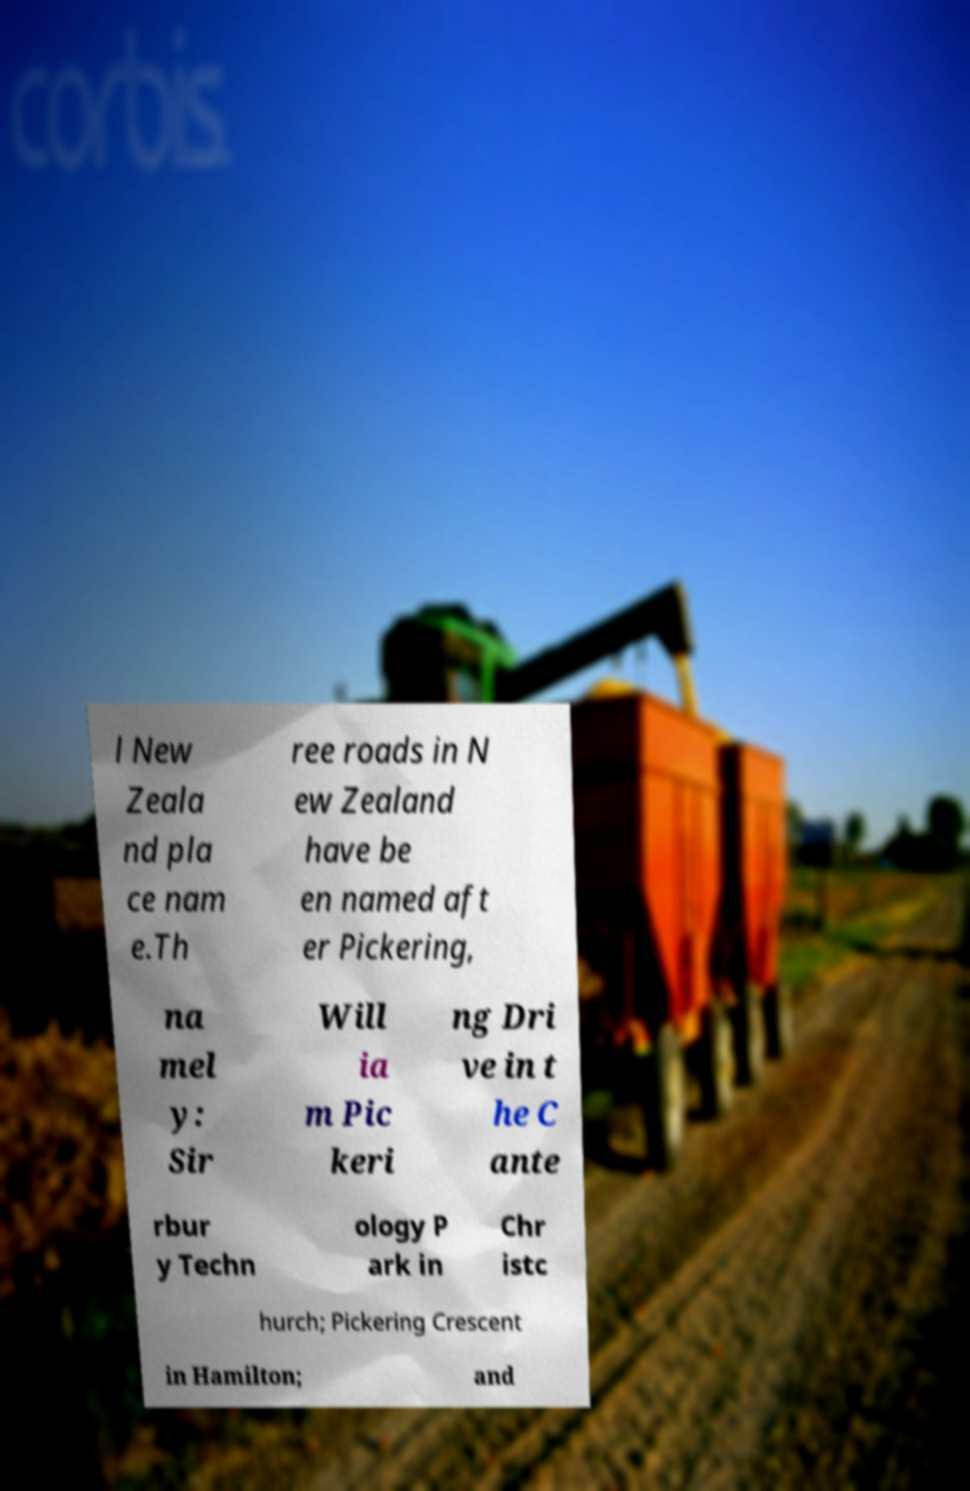Could you assist in decoding the text presented in this image and type it out clearly? l New Zeala nd pla ce nam e.Th ree roads in N ew Zealand have be en named aft er Pickering, na mel y: Sir Will ia m Pic keri ng Dri ve in t he C ante rbur y Techn ology P ark in Chr istc hurch; Pickering Crescent in Hamilton; and 